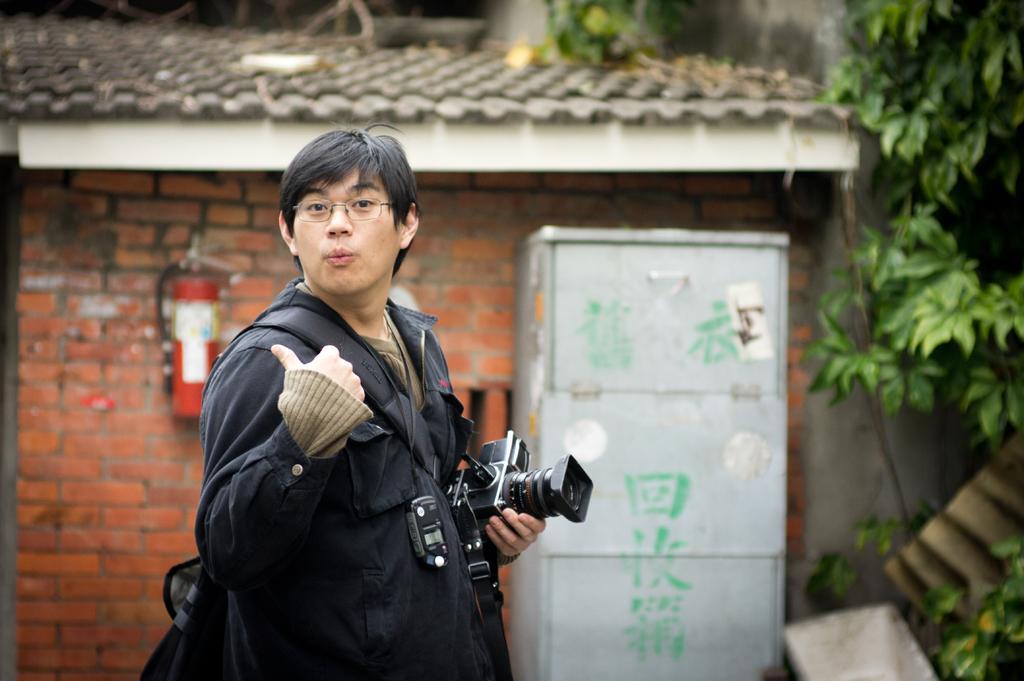In one or two sentences, can you explain what this image depicts? As we can see in the image, there is a man standing in the front. He is wearing spectacles and holding camera in his hand. Behind him there is a red color brick wall. On the right side there is a tree. 